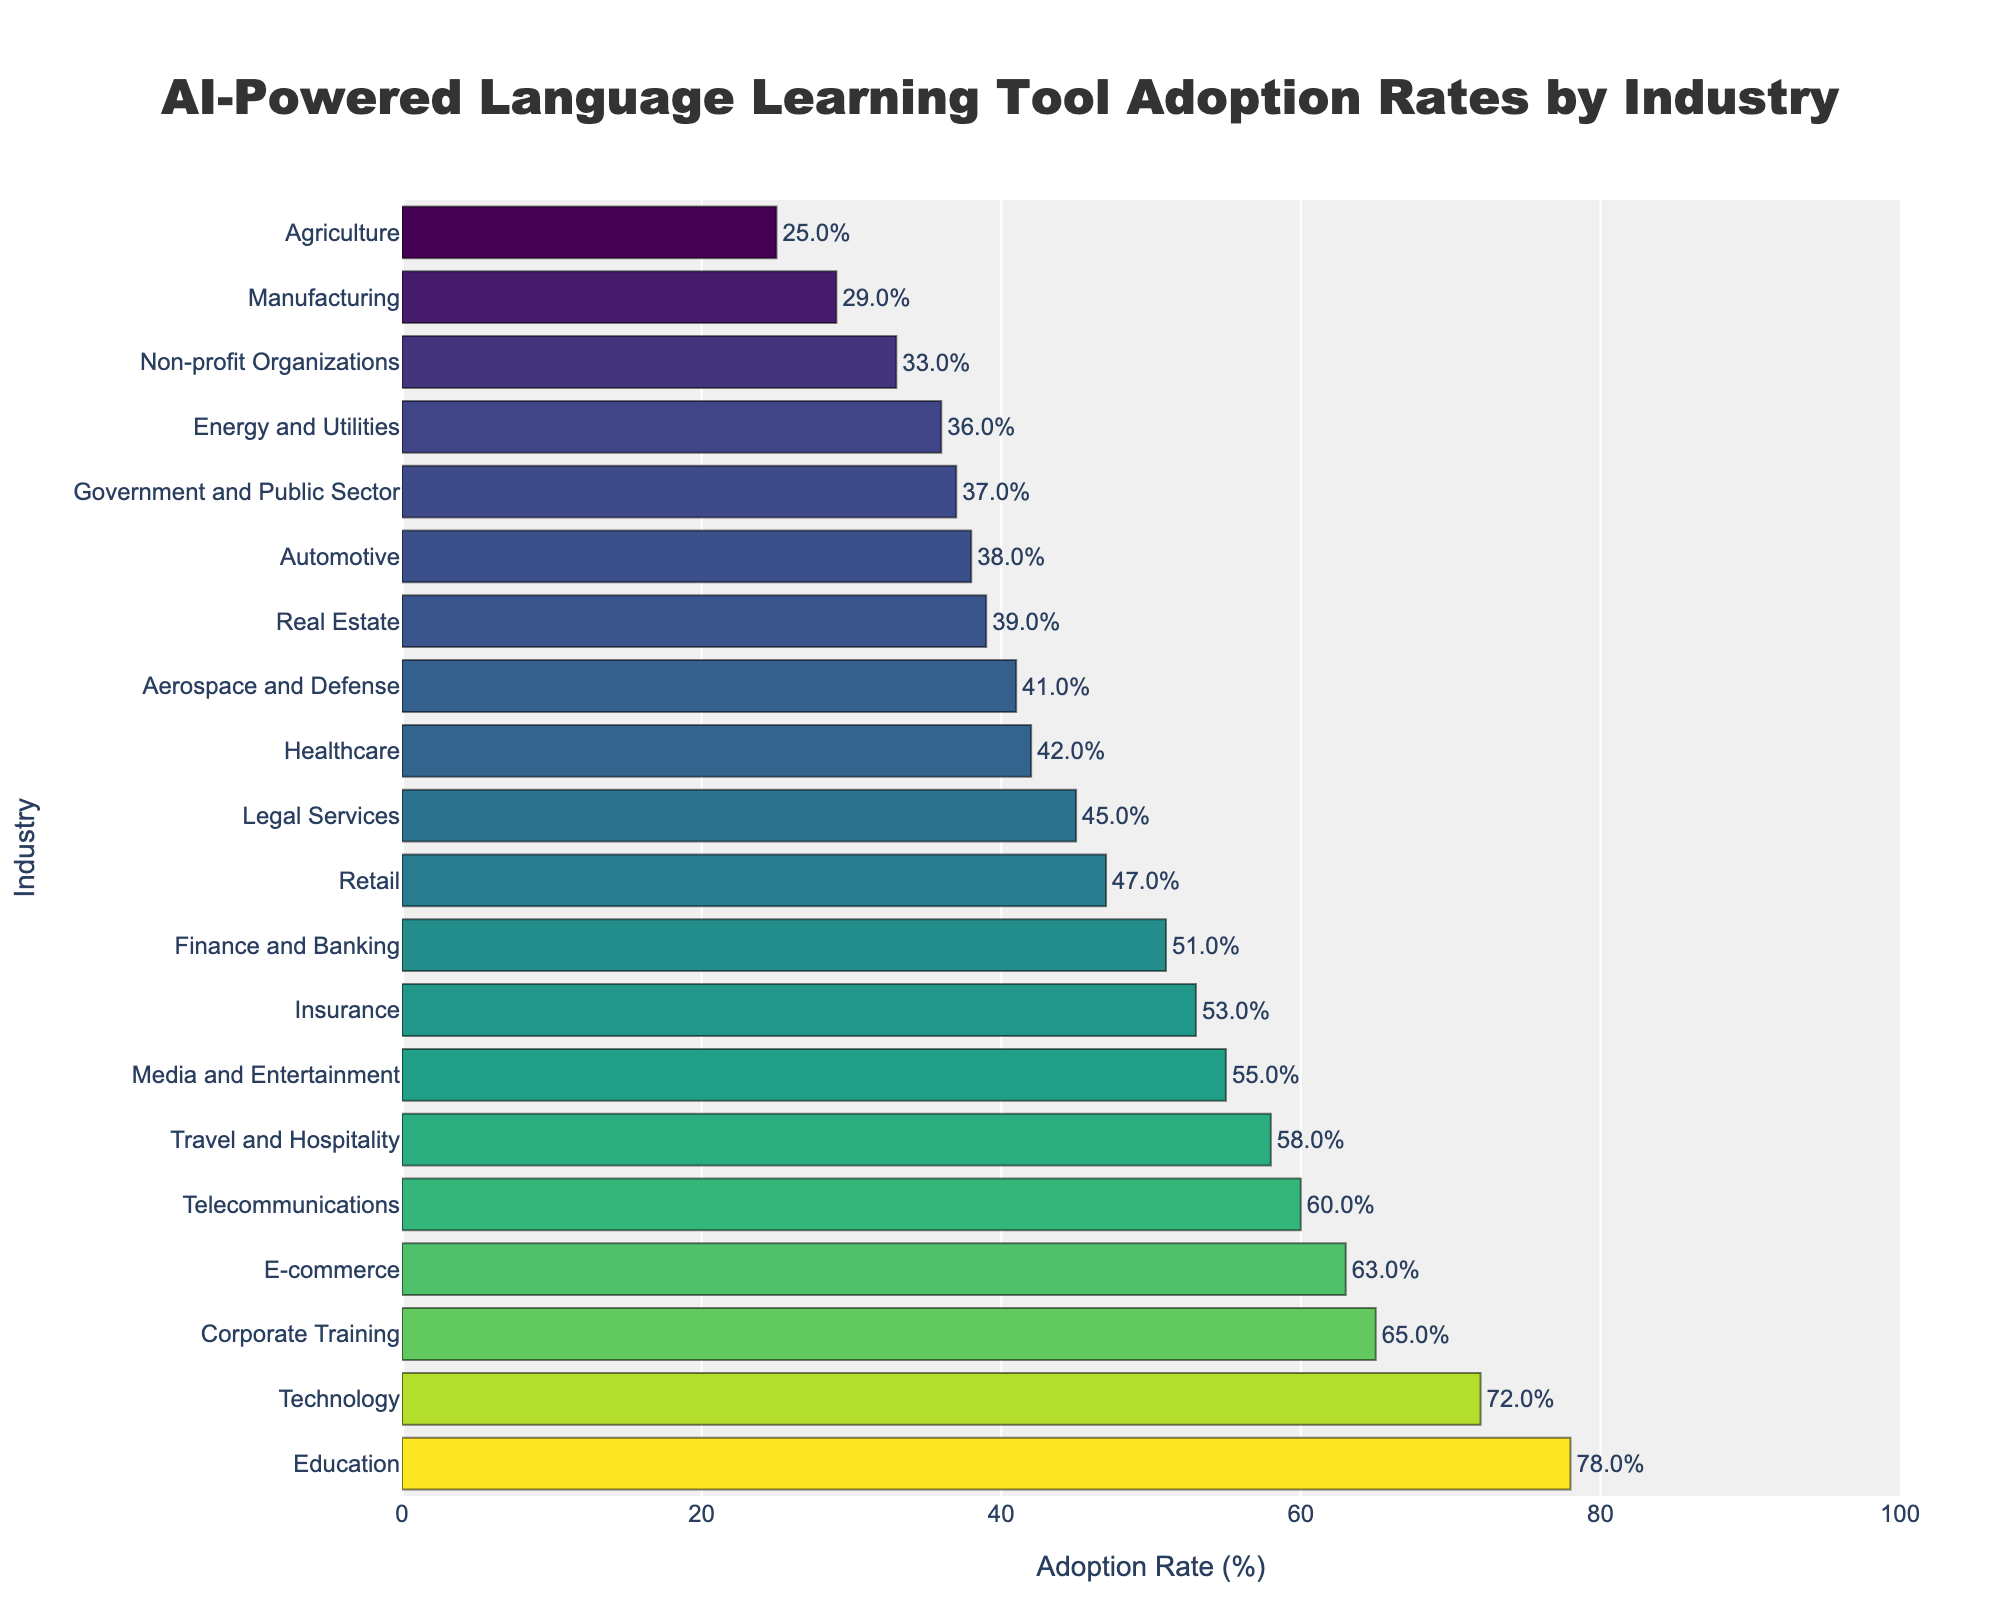What's the industry with the highest adoption rate of AI-powered language learning tools? The industry with the highest adoption rate can be identified by looking for the longest bar at the top of the bar chart. The 'Education' industry's bar is the longest, indicating it has the highest adoption rate.
Answer: Education Which two industries have the lowest adoption rates, and what are their rates? To find the two industries with the lowest adoption rates, look at the shortest bars. The 'Agriculture' industry has the shortest bar with a 25% adoption rate, followed by the 'Manufacturing' industry with a 29% adoption rate.
Answer: Agriculture (25%) and Manufacturing (29%) What is the difference in adoption rates between the Technology and Healthcare industries? To find the difference, identify the adoption rates of the 'Technology' and 'Healthcare' industries. The 'Technology' industry has a 72% adoption rate, and the 'Healthcare' industry has a 42% adoption rate. The difference is 72% - 42% = 30%.
Answer: 30% Which industries have an adoption rate above 60%? To determine this, look for bars extending beyond the 60% mark. The industries with adoption rates above 60% are 'Education' (78%), 'Technology' (72%), 'Corporate Training' (65%), 'E-commerce' (63%), and 'Telecommunications' (60%).
Answer: Education, Technology, Corporate Training, E-commerce, Telecommunications How many industries have adoption rates between 40% and 50%, inclusive? To count the industries within this range, find the bars that fall between these two percentages. These industries are 'Healthcare' (42%), 'Legal Services' (45%), 'Retail' (47%), and 'Insurance' (53%), making a total of 4 industries.
Answer: 4 What is the total adoption rate for the Education, Technology, and Media and Entertainment industries combined? Calculate the combined adoption rate by adding the individual rates: Education (78%), Technology (72%), and Media and Entertainment (55%). The total is 78% + 72% + 55% = 205%.
Answer: 205% Rank the Government and Public Sector, Aerospace and Defense, and Insurance industries in descending order of their adoption rates. Find the adoption rates of the 'Government and Public Sector' (37%), 'Aerospace and Defense' (41%), and 'Insurance' (53%) industries. Rank them as follows: Insurance (53%), Aerospace and Defense (41%), Government and Public Sector (37%).
Answer: Insurance, Aerospace and Defense, Government and Public Sector Which industry has an adoption rate closest to 50%? Identify the industries with rates near 50% and find the closest one. The 'Finance and Banking' industry has a 51% adoption rate, which is closest to 50%.
Answer: Finance and Banking What is the average adoption rate among the listed industries? Add all the adoption rates and divide by the number of industries. The sum is 943% for 20 industries, so the average is 943% / 20 = 47.15%.
Answer: 47.15% What is the median adoption rate among the listed industries? To find the median, list all adoption rates in ascending order and find the middle value. The values are: [25, 29, 33, 36, 37, 38, 39, 41, 42, 45, 47, 51, 53, 55, 58, 60, 63, 65, 72, 78]. The median is the average of the 10th and 11th values: (45 + 47) / 2 = 46%.
Answer: 46% 